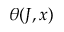<formula> <loc_0><loc_0><loc_500><loc_500>\theta ( J , x )</formula> 